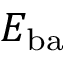<formula> <loc_0><loc_0><loc_500><loc_500>E _ { b a }</formula> 